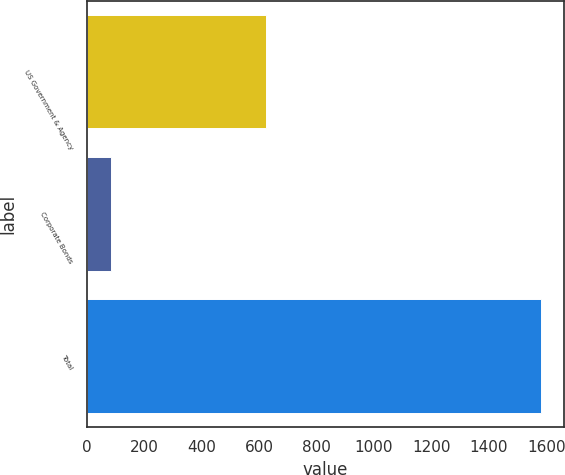Convert chart to OTSL. <chart><loc_0><loc_0><loc_500><loc_500><bar_chart><fcel>US Government & Agency<fcel>Corporate Bonds<fcel>Total<nl><fcel>624<fcel>83<fcel>1583<nl></chart> 